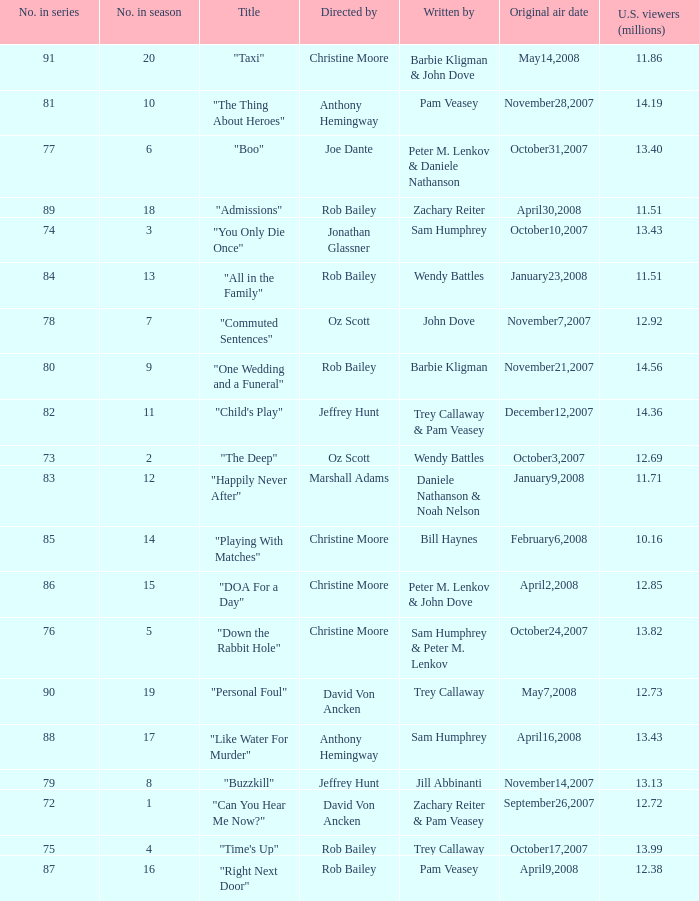Parse the table in full. {'header': ['No. in series', 'No. in season', 'Title', 'Directed by', 'Written by', 'Original air date', 'U.S. viewers (millions)'], 'rows': [['91', '20', '"Taxi"', 'Christine Moore', 'Barbie Kligman & John Dove', 'May14,2008', '11.86'], ['81', '10', '"The Thing About Heroes"', 'Anthony Hemingway', 'Pam Veasey', 'November28,2007', '14.19'], ['77', '6', '"Boo"', 'Joe Dante', 'Peter M. Lenkov & Daniele Nathanson', 'October31,2007', '13.40'], ['89', '18', '"Admissions"', 'Rob Bailey', 'Zachary Reiter', 'April30,2008', '11.51'], ['74', '3', '"You Only Die Once"', 'Jonathan Glassner', 'Sam Humphrey', 'October10,2007', '13.43'], ['84', '13', '"All in the Family"', 'Rob Bailey', 'Wendy Battles', 'January23,2008', '11.51'], ['78', '7', '"Commuted Sentences"', 'Oz Scott', 'John Dove', 'November7,2007', '12.92'], ['80', '9', '"One Wedding and a Funeral"', 'Rob Bailey', 'Barbie Kligman', 'November21,2007', '14.56'], ['82', '11', '"Child\'s Play"', 'Jeffrey Hunt', 'Trey Callaway & Pam Veasey', 'December12,2007', '14.36'], ['73', '2', '"The Deep"', 'Oz Scott', 'Wendy Battles', 'October3,2007', '12.69'], ['83', '12', '"Happily Never After"', 'Marshall Adams', 'Daniele Nathanson & Noah Nelson', 'January9,2008', '11.71'], ['85', '14', '"Playing With Matches"', 'Christine Moore', 'Bill Haynes', 'February6,2008', '10.16'], ['86', '15', '"DOA For a Day"', 'Christine Moore', 'Peter M. Lenkov & John Dove', 'April2,2008', '12.85'], ['76', '5', '"Down the Rabbit Hole"', 'Christine Moore', 'Sam Humphrey & Peter M. Lenkov', 'October24,2007', '13.82'], ['90', '19', '"Personal Foul"', 'David Von Ancken', 'Trey Callaway', 'May7,2008', '12.73'], ['88', '17', '"Like Water For Murder"', 'Anthony Hemingway', 'Sam Humphrey', 'April16,2008', '13.43'], ['79', '8', '"Buzzkill"', 'Jeffrey Hunt', 'Jill Abbinanti', 'November14,2007', '13.13'], ['72', '1', '"Can You Hear Me Now?"', 'David Von Ancken', 'Zachary Reiter & Pam Veasey', 'September26,2007', '12.72'], ['75', '4', '"Time\'s Up"', 'Rob Bailey', 'Trey Callaway', 'October17,2007', '13.99'], ['87', '16', '"Right Next Door"', 'Rob Bailey', 'Pam Veasey', 'April9,2008', '12.38']]} How many millions of U.S. viewers watched the episode directed by Rob Bailey and written by Pam Veasey? 12.38. 